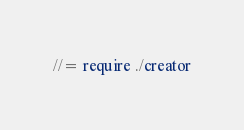<code> <loc_0><loc_0><loc_500><loc_500><_CSS_>//= require ./creator
</code> 